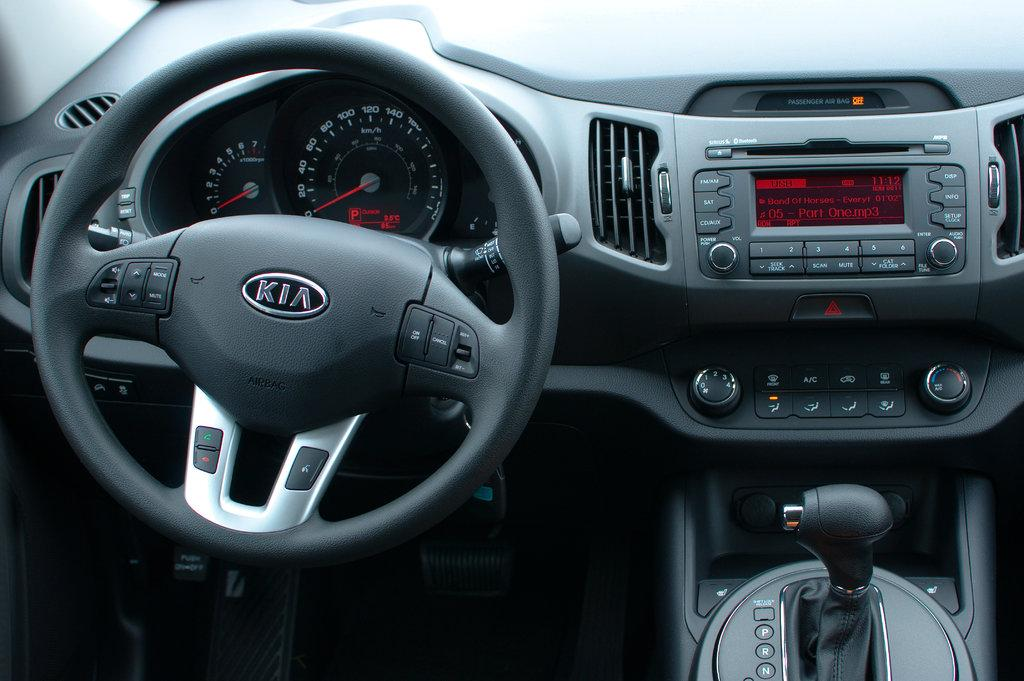Where was the image taken? The image is taken inside of a car. What can be seen in the driver's area of the car? There is a steering wheel, a gear, and a dashboard in the image. What type of object is present on the dashboard? There is a tape in the image. What type of quiver is visible in the image? There is no quiver present in the image; it is taken inside a car. What color is the underwear of the person driving the car in the image? There is no person visible in the image, and therefore no underwear can be observed. 